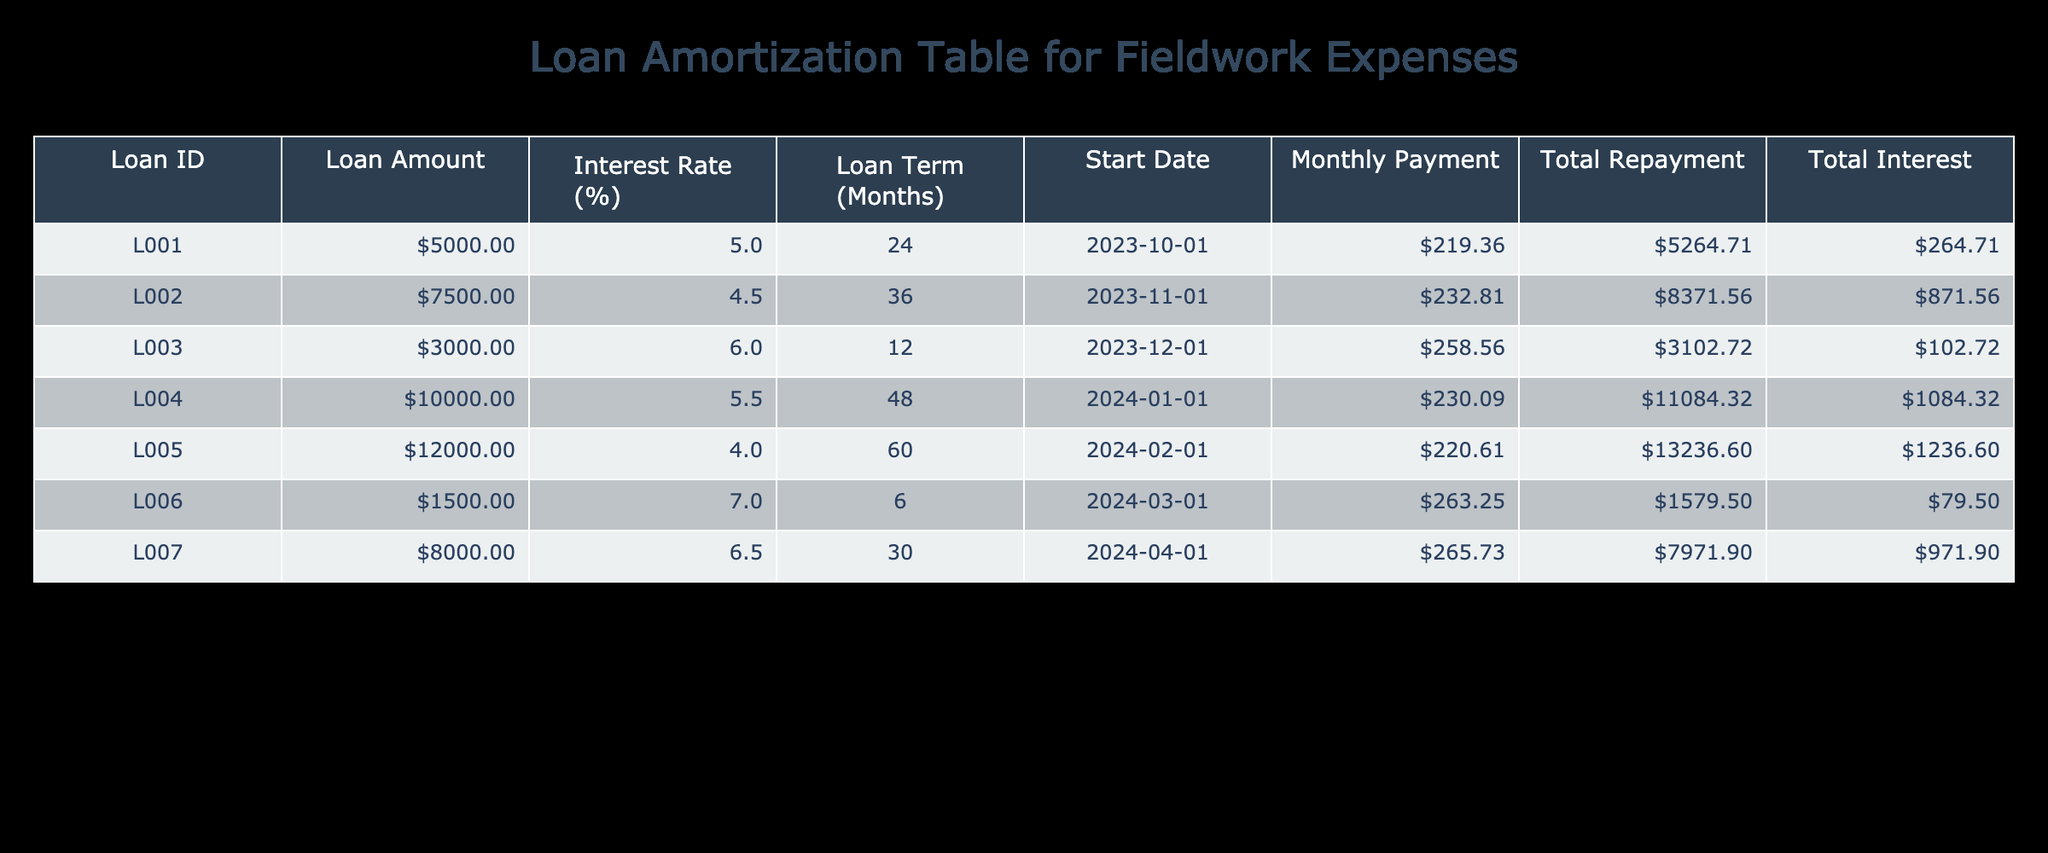What is the loan amount for Loan ID L003? Looking at the table under the "Loan Amount" column for Loan ID L003, the value is 3000.
Answer: 3000 What is the monthly payment for Loan ID L001? Checking the "Monthly Payment" column for Loan ID L001, the amount listed is 219.36.
Answer: 219.36 Which loan has the highest total interest paid? Reviewing the "Total Interest" column, Loan ID L005 has the highest value of 1236.60.
Answer: L005 What is the total repayment amount for loan L004 compared to L006? In the table, the "Total Repayment" for Loan ID L004 is 11084.32 and for Loan ID L006 it is 1579.50. The difference is 11084.32 - 1579.50 = 9524.82.
Answer: 9524.82 Is the loan term for Loan ID L002 longer than Loan ID L003? The loan term for Loan ID L002 is 36 months and for Loan ID L003 it is 12 months. Since 36 is greater than 12, the answer is yes.
Answer: Yes What is the average interest rate of all loans listed? To find the average interest rate, we sum the interest rates: 5.0 + 4.5 + 6.0 + 5.5 + 4.0 + 7.0 + 6.5 = 38.5. There are 7 loans, so the average is 38.5 / 7 = 5.5.
Answer: 5.5 How much more is the total repayment of Loan ID L005 compared to Loan ID L001? Loan ID L005 has a total repayment of 13236.60 and Loan ID L001 has 5264.71. The difference is 13236.60 - 5264.71 = 7961.89.
Answer: 7961.89 Does Loan ID L007 have a lower monthly payment than Loan ID L002? The monthly payment for Loan ID L007 is 265.73, while for Loan ID L002 it is 232.81. Since 265.73 is greater than 232.81, the answer is no.
Answer: No 